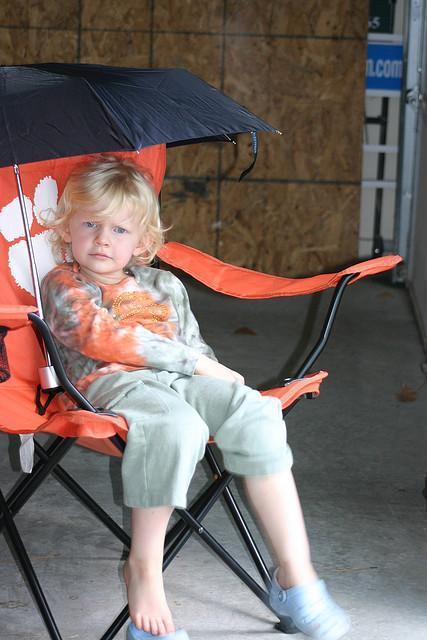How many shoes is the kid wearing?
Give a very brief answer. 1. 